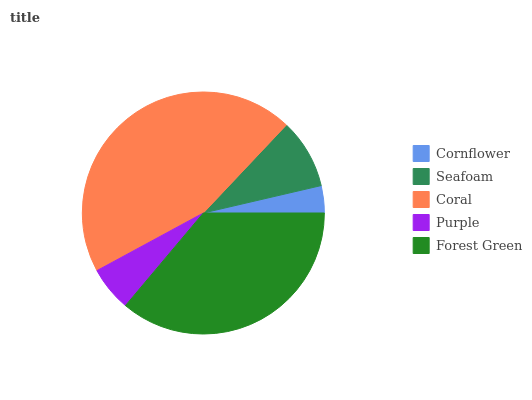Is Cornflower the minimum?
Answer yes or no. Yes. Is Coral the maximum?
Answer yes or no. Yes. Is Seafoam the minimum?
Answer yes or no. No. Is Seafoam the maximum?
Answer yes or no. No. Is Seafoam greater than Cornflower?
Answer yes or no. Yes. Is Cornflower less than Seafoam?
Answer yes or no. Yes. Is Cornflower greater than Seafoam?
Answer yes or no. No. Is Seafoam less than Cornflower?
Answer yes or no. No. Is Seafoam the high median?
Answer yes or no. Yes. Is Seafoam the low median?
Answer yes or no. Yes. Is Forest Green the high median?
Answer yes or no. No. Is Cornflower the low median?
Answer yes or no. No. 